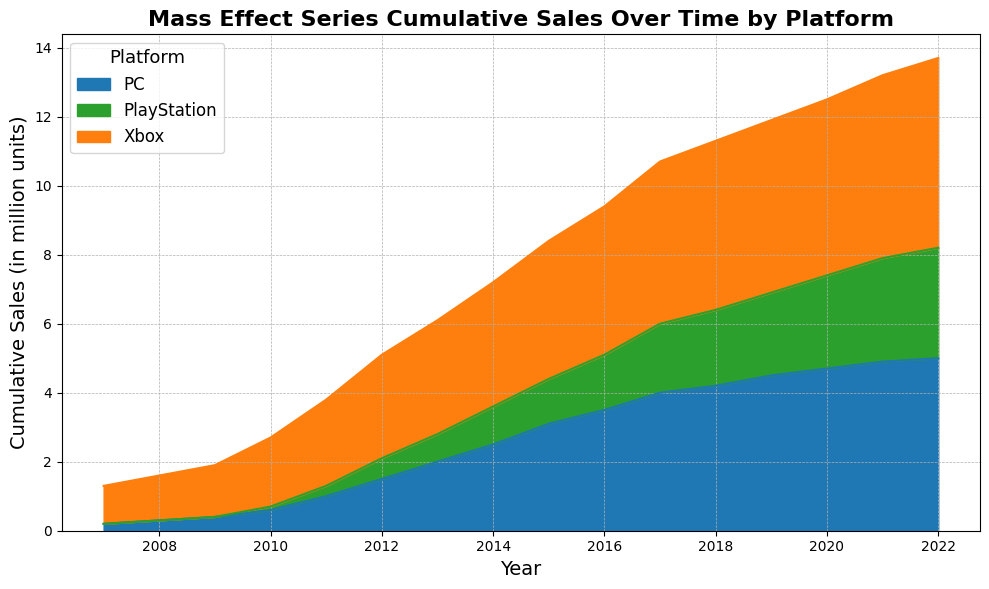What is the cumulative sales on PC in the year 2010? Look at the height of the area for PC in 2010 in the figure and read off the corresponding sales value.
Answer: 0.6 million units Which platform had the highest cumulative sales in 2022? Compare the heights of the areas for each platform in 2022 and identify the tallest one, corresponding to Xbox.
Answer: Xbox How did the cumulative sales for PlayStation change from 2010 to 2011? Subtract the cumulative sales value for PlayStation in 2010 from its value in 2011 (0.3 - 0.1).
Answer: Increased by 0.2 million units Between which two consecutive years did Xbox see the largest increase in cumulative sales? Check the incremental height of the area for Xbox between each pair of consecutive years and identify the largest change. The largest increase is from 2010 to 2011.
Answer: 2010 to 2011 What is the general trend of cumulative sales for the PC platform over the years? Observe the overall shape of the PC area's height in the figure from left to right. It steadily increases each year.
Answer: Increasing By how much did total sales across all platforms increase from 2011 to 2012? Calculate the sum of the cumulative sales for all platforms in 2011 and compare it to the sum of all platforms in 2012. Subtract the total sales in 2011 from the total in 2012 (1.0+2.5+0.3) to (1.5+3.0+0.6).
Answer: 1.3 million units In what year did PlayStation cumulative sales reach 2 million units? Look for the year where the height of the PlayStation area first reaches or exceeds 2 million units.
Answer: 2017 What were the cumulative sales for Xbox in 2015? Reference the figure to read off the Xbox sales value in 2015.
Answer: 4.0 million units Comparing 2018 and 2020, which platform had the least increase in cumulative sales? Calculate the difference in cumulative sales for each platform between these two years and identify the smallest increase. PC: (4.7-4.2), Xbox: (5.1-4.9), PlayStation: (2.7-2.2).
Answer: Xbox 